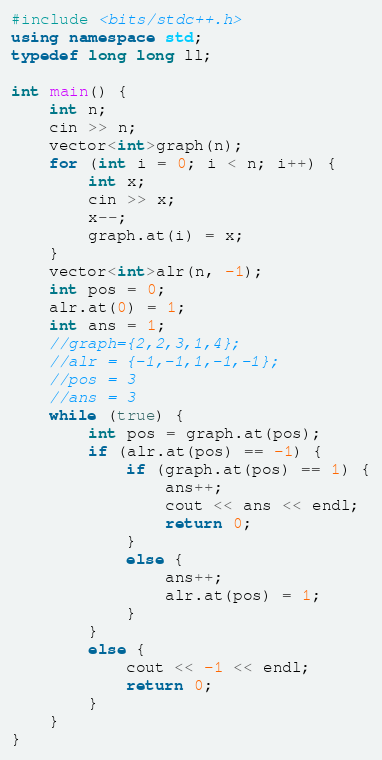<code> <loc_0><loc_0><loc_500><loc_500><_C++_>#include <bits/stdc++.h>
using namespace std;
typedef long long ll;

int main() {
	int n;
	cin >> n;
	vector<int>graph(n);
	for (int i = 0; i < n; i++) {
		int x;
		cin >> x;
		x--;
		graph.at(i) = x;
	}
	vector<int>alr(n, -1);
	int pos = 0;
	alr.at(0) = 1;
	int ans = 1;
	//graph={2,2,3,1,4};
	//alr = {-1,-1,1,-1,-1};
	//pos = 3
	//ans = 3
	while (true) {
		int pos = graph.at(pos);
		if (alr.at(pos) == -1) {
			if (graph.at(pos) == 1) {
				ans++;
				cout << ans << endl;
				return 0;
			}
			else {
				ans++;
				alr.at(pos) = 1;
			}
		}
		else {
			cout << -1 << endl;
			return 0;
		}
	}
}</code> 